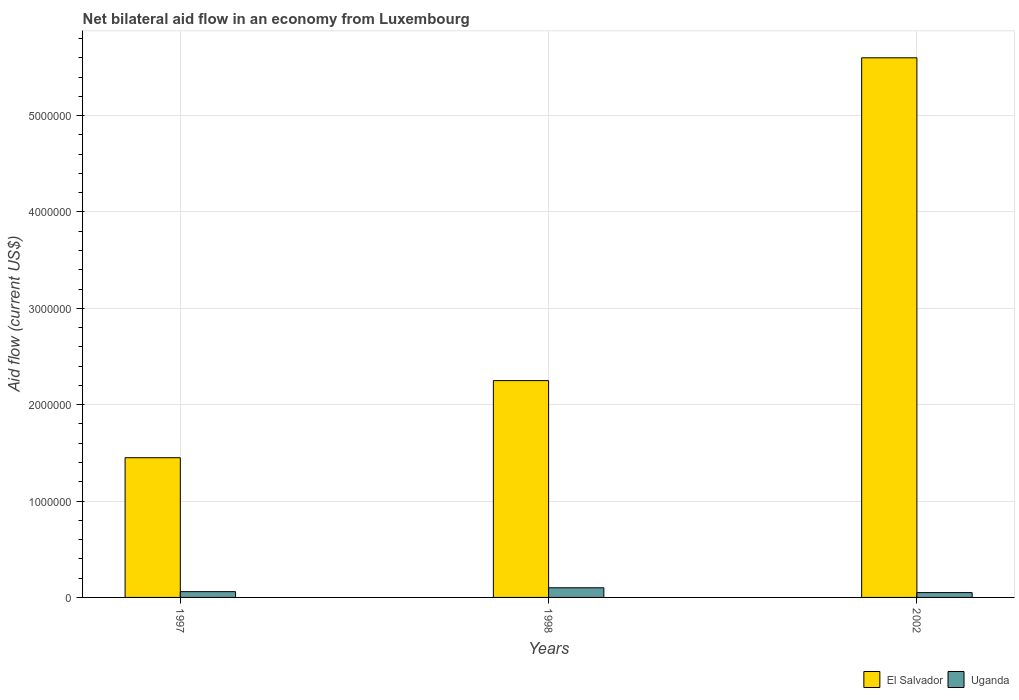Are the number of bars per tick equal to the number of legend labels?
Keep it short and to the point. Yes. Are the number of bars on each tick of the X-axis equal?
Keep it short and to the point. Yes. How many bars are there on the 1st tick from the left?
Offer a terse response. 2. How many bars are there on the 1st tick from the right?
Provide a short and direct response. 2. What is the net bilateral aid flow in El Salvador in 1998?
Offer a very short reply. 2.25e+06. Across all years, what is the maximum net bilateral aid flow in El Salvador?
Keep it short and to the point. 5.60e+06. What is the total net bilateral aid flow in Uganda in the graph?
Give a very brief answer. 2.10e+05. What is the difference between the net bilateral aid flow in El Salvador in 1998 and that in 2002?
Give a very brief answer. -3.35e+06. What is the difference between the net bilateral aid flow in Uganda in 1997 and the net bilateral aid flow in El Salvador in 1998?
Your answer should be compact. -2.19e+06. What is the average net bilateral aid flow in El Salvador per year?
Provide a succinct answer. 3.10e+06. In the year 2002, what is the difference between the net bilateral aid flow in Uganda and net bilateral aid flow in El Salvador?
Keep it short and to the point. -5.55e+06. In how many years, is the net bilateral aid flow in Uganda greater than 1800000 US$?
Ensure brevity in your answer.  0. What is the ratio of the net bilateral aid flow in El Salvador in 1997 to that in 1998?
Your answer should be compact. 0.64. Is the difference between the net bilateral aid flow in Uganda in 1998 and 2002 greater than the difference between the net bilateral aid flow in El Salvador in 1998 and 2002?
Make the answer very short. Yes. What is the difference between the highest and the second highest net bilateral aid flow in Uganda?
Give a very brief answer. 4.00e+04. What is the difference between the highest and the lowest net bilateral aid flow in El Salvador?
Offer a terse response. 4.15e+06. In how many years, is the net bilateral aid flow in El Salvador greater than the average net bilateral aid flow in El Salvador taken over all years?
Make the answer very short. 1. Is the sum of the net bilateral aid flow in El Salvador in 1998 and 2002 greater than the maximum net bilateral aid flow in Uganda across all years?
Your response must be concise. Yes. What does the 1st bar from the left in 2002 represents?
Ensure brevity in your answer.  El Salvador. What does the 2nd bar from the right in 1998 represents?
Your response must be concise. El Salvador. How many bars are there?
Offer a very short reply. 6. What is the difference between two consecutive major ticks on the Y-axis?
Your answer should be very brief. 1.00e+06. How are the legend labels stacked?
Provide a succinct answer. Horizontal. What is the title of the graph?
Give a very brief answer. Net bilateral aid flow in an economy from Luxembourg. Does "High income" appear as one of the legend labels in the graph?
Your answer should be very brief. No. What is the label or title of the X-axis?
Your answer should be compact. Years. What is the Aid flow (current US$) in El Salvador in 1997?
Your answer should be very brief. 1.45e+06. What is the Aid flow (current US$) of El Salvador in 1998?
Ensure brevity in your answer.  2.25e+06. What is the Aid flow (current US$) in Uganda in 1998?
Provide a short and direct response. 1.00e+05. What is the Aid flow (current US$) in El Salvador in 2002?
Offer a terse response. 5.60e+06. Across all years, what is the maximum Aid flow (current US$) in El Salvador?
Give a very brief answer. 5.60e+06. Across all years, what is the minimum Aid flow (current US$) in El Salvador?
Your response must be concise. 1.45e+06. What is the total Aid flow (current US$) of El Salvador in the graph?
Provide a succinct answer. 9.30e+06. What is the total Aid flow (current US$) of Uganda in the graph?
Your answer should be very brief. 2.10e+05. What is the difference between the Aid flow (current US$) of El Salvador in 1997 and that in 1998?
Your answer should be compact. -8.00e+05. What is the difference between the Aid flow (current US$) in El Salvador in 1997 and that in 2002?
Your answer should be very brief. -4.15e+06. What is the difference between the Aid flow (current US$) of El Salvador in 1998 and that in 2002?
Your response must be concise. -3.35e+06. What is the difference between the Aid flow (current US$) in El Salvador in 1997 and the Aid flow (current US$) in Uganda in 1998?
Make the answer very short. 1.35e+06. What is the difference between the Aid flow (current US$) of El Salvador in 1997 and the Aid flow (current US$) of Uganda in 2002?
Make the answer very short. 1.40e+06. What is the difference between the Aid flow (current US$) in El Salvador in 1998 and the Aid flow (current US$) in Uganda in 2002?
Your answer should be very brief. 2.20e+06. What is the average Aid flow (current US$) of El Salvador per year?
Your response must be concise. 3.10e+06. In the year 1997, what is the difference between the Aid flow (current US$) in El Salvador and Aid flow (current US$) in Uganda?
Your answer should be compact. 1.39e+06. In the year 1998, what is the difference between the Aid flow (current US$) of El Salvador and Aid flow (current US$) of Uganda?
Your response must be concise. 2.15e+06. In the year 2002, what is the difference between the Aid flow (current US$) in El Salvador and Aid flow (current US$) in Uganda?
Offer a terse response. 5.55e+06. What is the ratio of the Aid flow (current US$) in El Salvador in 1997 to that in 1998?
Your answer should be very brief. 0.64. What is the ratio of the Aid flow (current US$) in Uganda in 1997 to that in 1998?
Ensure brevity in your answer.  0.6. What is the ratio of the Aid flow (current US$) of El Salvador in 1997 to that in 2002?
Give a very brief answer. 0.26. What is the ratio of the Aid flow (current US$) of El Salvador in 1998 to that in 2002?
Your answer should be compact. 0.4. What is the difference between the highest and the second highest Aid flow (current US$) of El Salvador?
Provide a short and direct response. 3.35e+06. What is the difference between the highest and the second highest Aid flow (current US$) of Uganda?
Keep it short and to the point. 4.00e+04. What is the difference between the highest and the lowest Aid flow (current US$) in El Salvador?
Make the answer very short. 4.15e+06. 